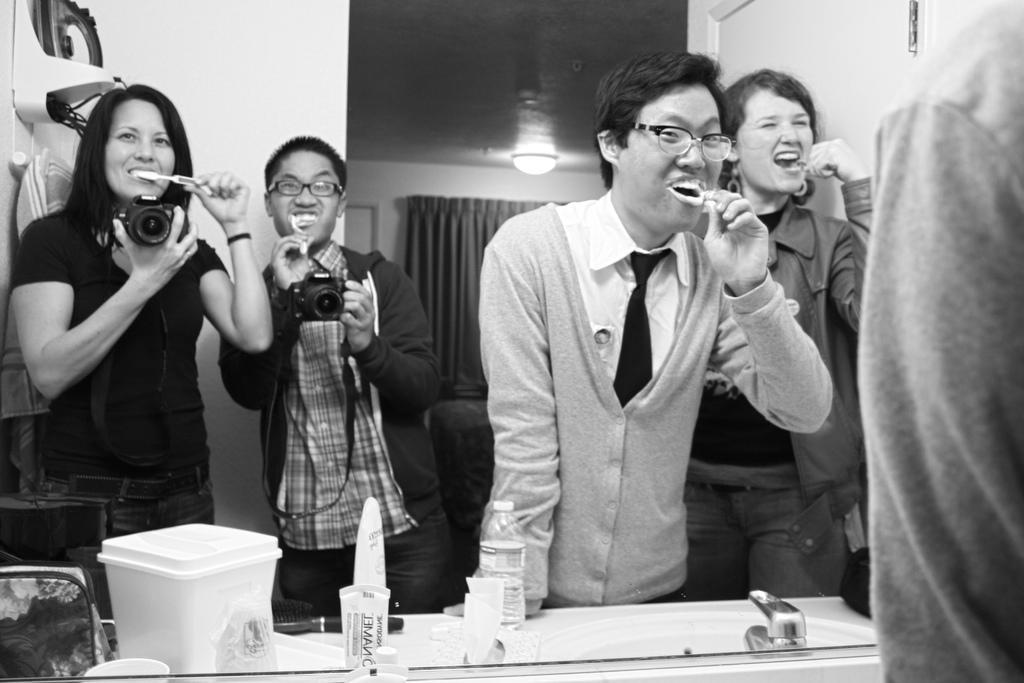Could you give a brief overview of what you see in this image? In the middle of the image few people are brushing and looking in to the mirror and these two people are standing and holding cameras in their hands. Bottom left side of the image there are some products. 